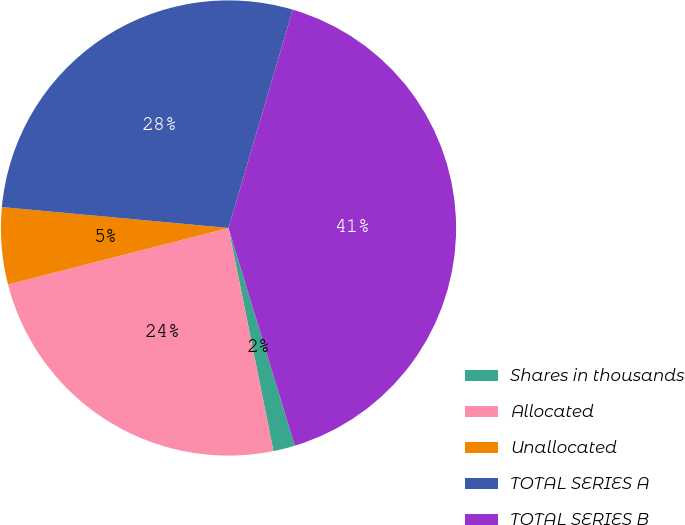Convert chart to OTSL. <chart><loc_0><loc_0><loc_500><loc_500><pie_chart><fcel>Shares in thousands<fcel>Allocated<fcel>Unallocated<fcel>TOTAL SERIES A<fcel>TOTAL SERIES B<nl><fcel>1.54%<fcel>24.17%<fcel>5.46%<fcel>28.09%<fcel>40.74%<nl></chart> 